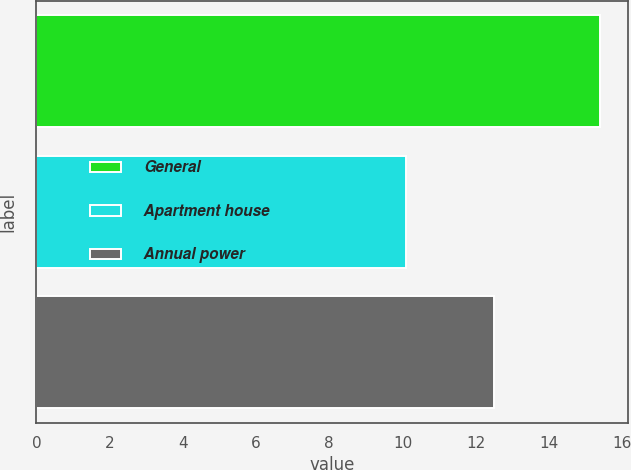<chart> <loc_0><loc_0><loc_500><loc_500><bar_chart><fcel>General<fcel>Apartment house<fcel>Annual power<nl><fcel>15.4<fcel>10.1<fcel>12.5<nl></chart> 